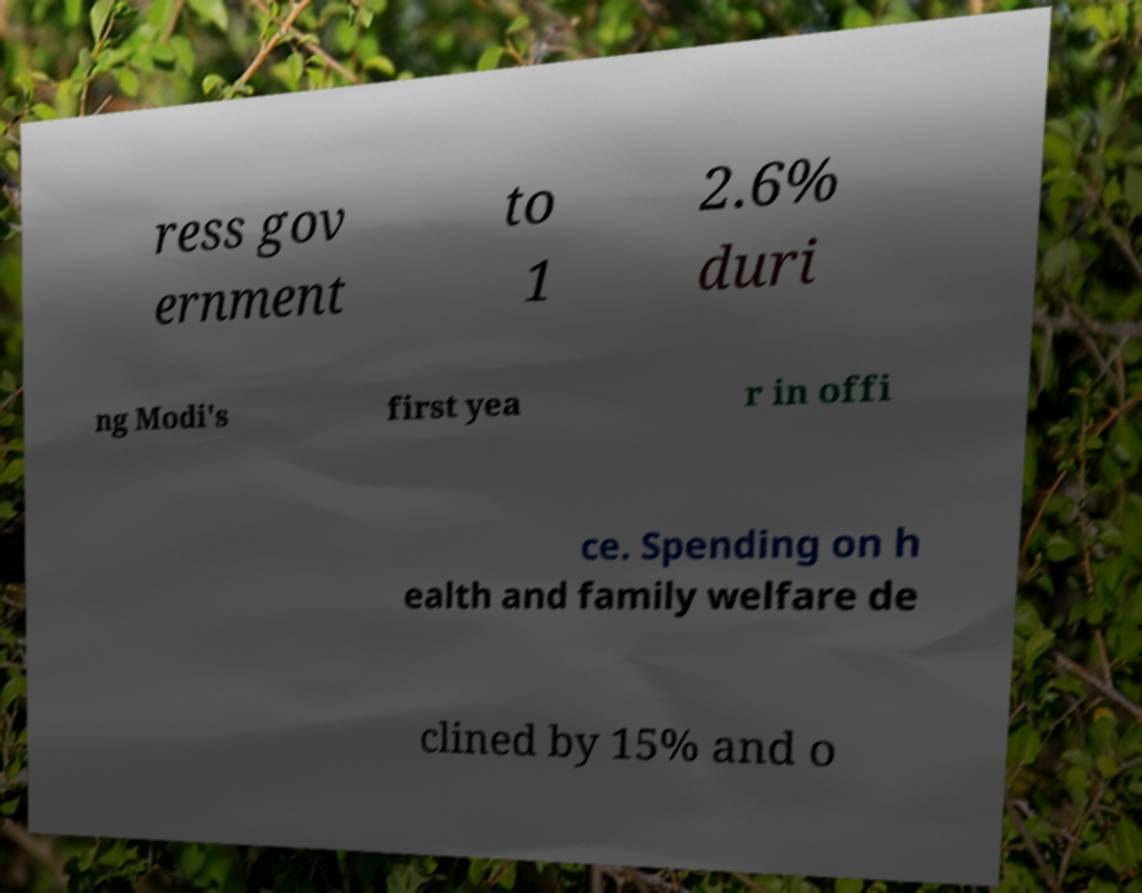For documentation purposes, I need the text within this image transcribed. Could you provide that? ress gov ernment to 1 2.6% duri ng Modi's first yea r in offi ce. Spending on h ealth and family welfare de clined by 15% and o 